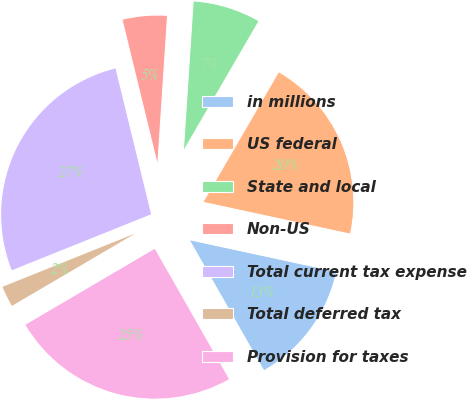Convert chart to OTSL. <chart><loc_0><loc_0><loc_500><loc_500><pie_chart><fcel>in millions<fcel>US federal<fcel>State and local<fcel>Non-US<fcel>Total current tax expense<fcel>Total deferred tax<fcel>Provision for taxes<nl><fcel>13.37%<fcel>20.02%<fcel>7.33%<fcel>4.85%<fcel>27.28%<fcel>2.37%<fcel>24.8%<nl></chart> 